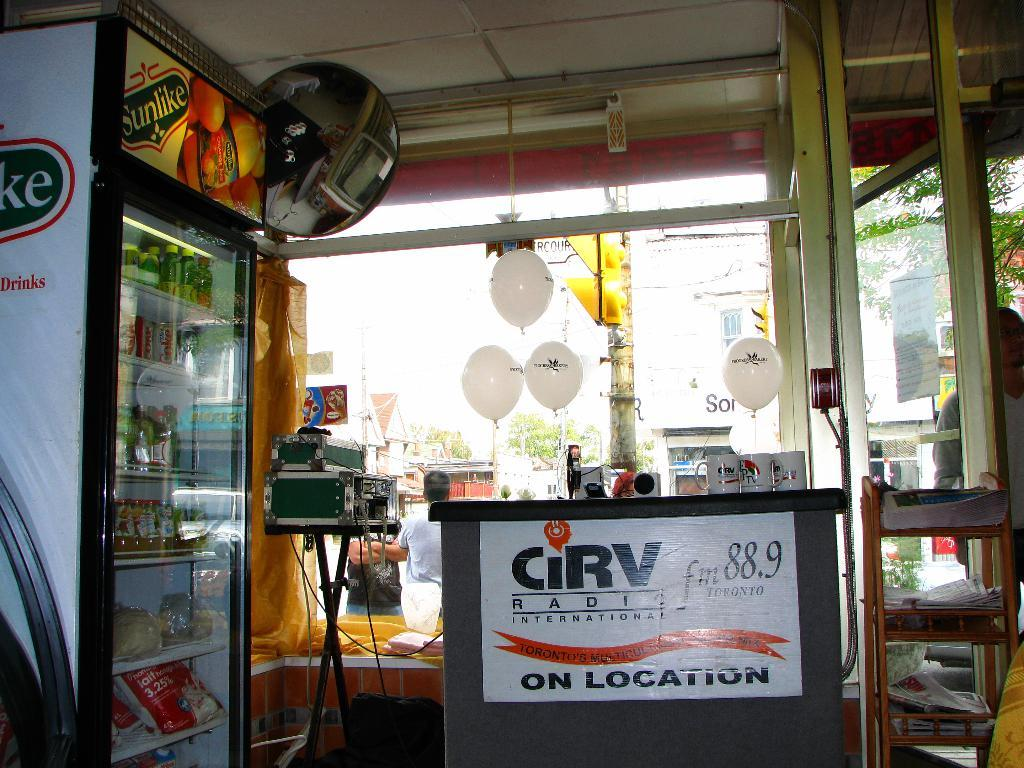<image>
Share a concise interpretation of the image provided. CiRV radio 88.9 is advertising on a white sign near a Sunlike drink display and cooler. 